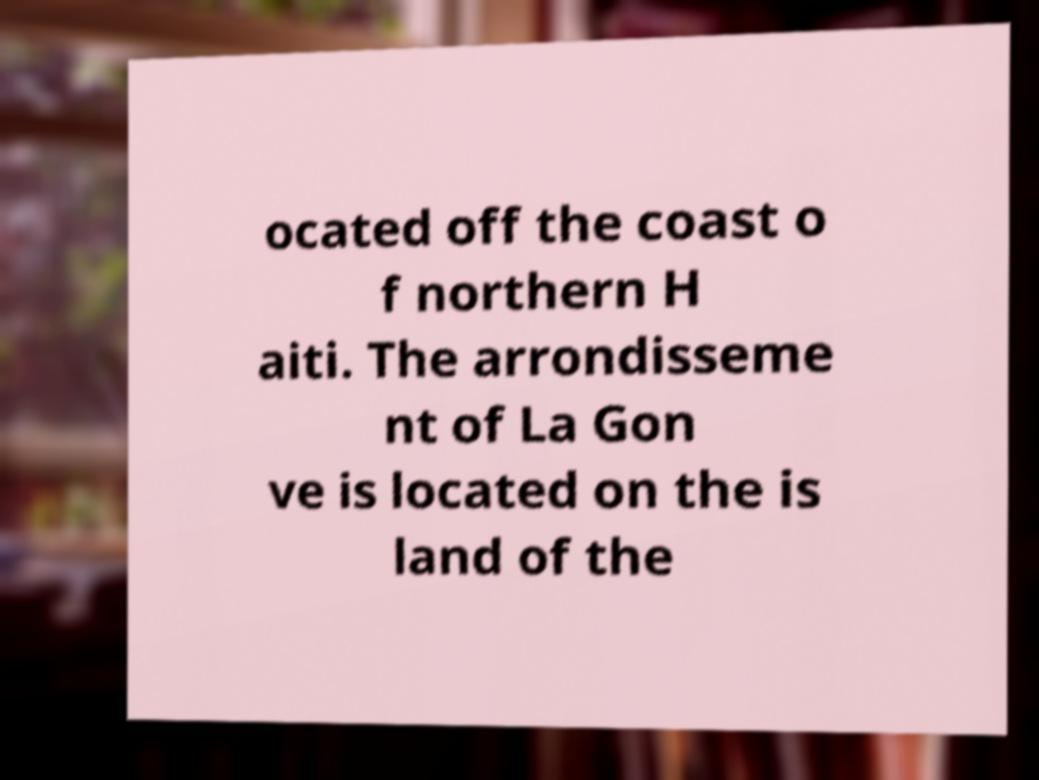Can you read and provide the text displayed in the image?This photo seems to have some interesting text. Can you extract and type it out for me? ocated off the coast o f northern H aiti. The arrondisseme nt of La Gon ve is located on the is land of the 